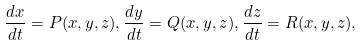Convert formula to latex. <formula><loc_0><loc_0><loc_500><loc_500>\frac { d x } { d t } = P ( x , y , z ) , \frac { d y } { d t } = Q ( x , y , z ) , \frac { d z } { d t } = R ( x , y , z ) ,</formula> 